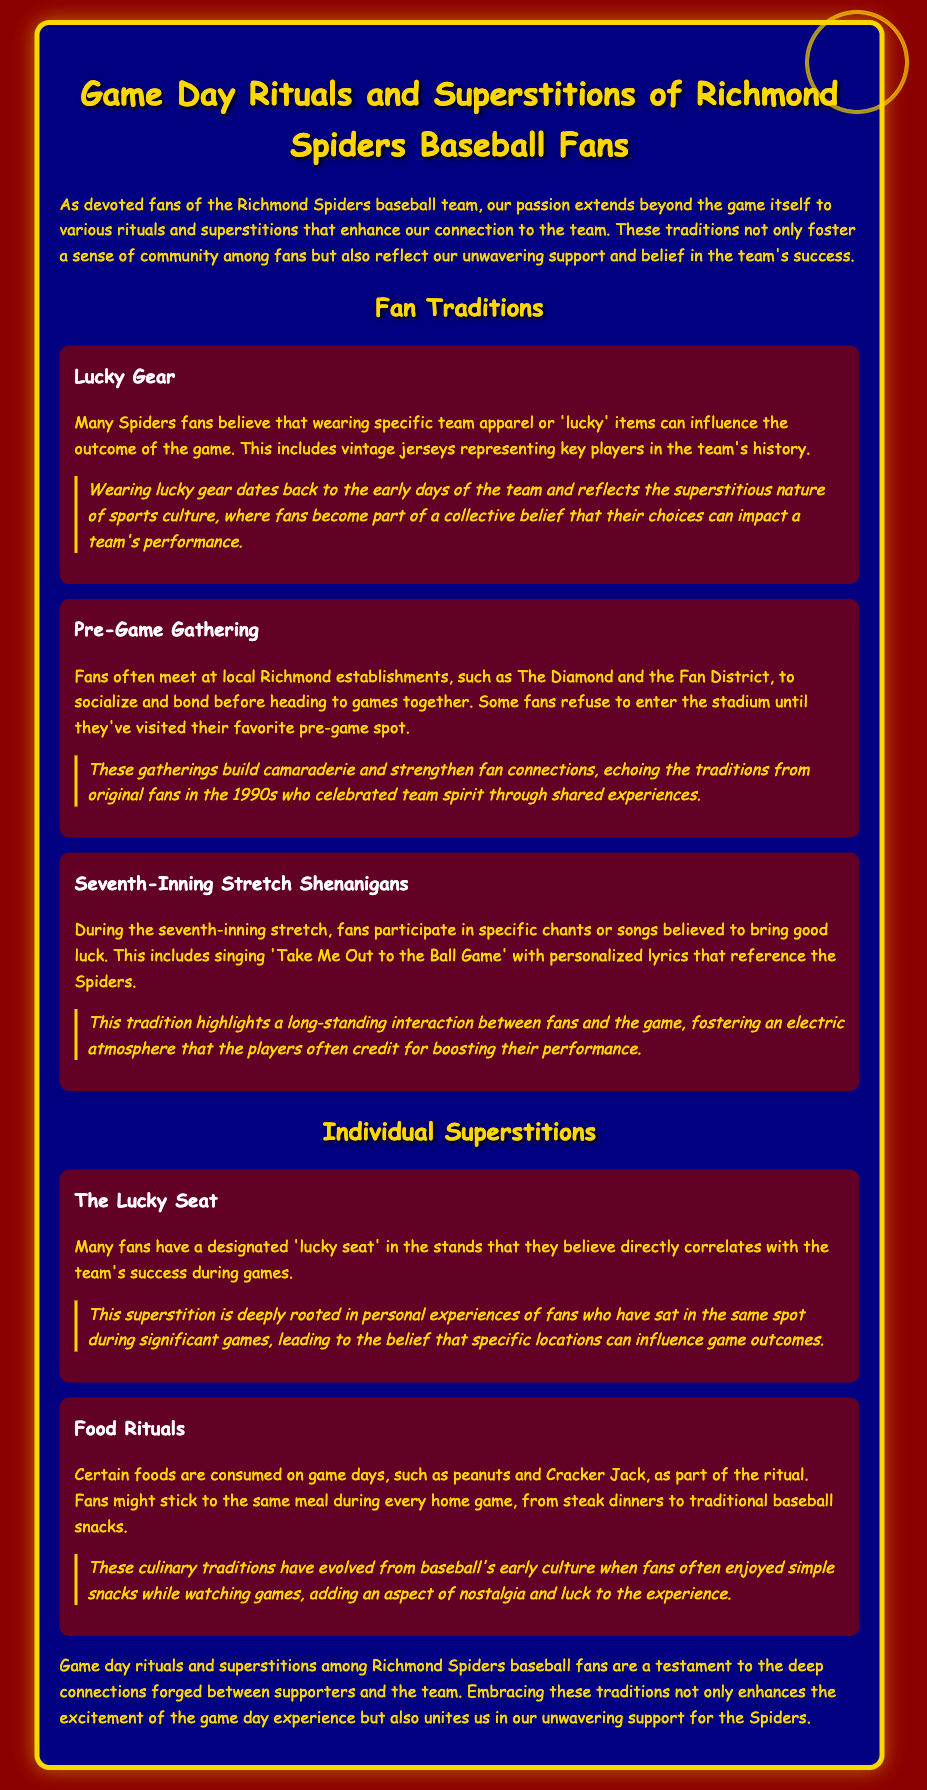what is the title of the memo? The title of the memo is located in the main heading at the top of the document.
Answer: Game Day Rituals and Superstitions of Richmond Spiders Baseball Fans what is the historical significance of wearing lucky gear? The historical significance is described in the section on "Lucky Gear," which explains the connection to sports culture.
Answer: Reflects the superstitious nature of sports culture what do fans do during the seventh-inning stretch? The activities during the seventh-inning stretch are outlined in specific mentions under the respective tradition.
Answer: Participate in specific chants or songs how many traditions are mentioned in the document? There are three traditions detailed in the memo.
Answer: Three what is a common food ritual mentioned for game days? The food ritual is noted in the section on "Food Rituals," highlighting what fans typically eat.
Answer: Peanuts and Cracker Jack what is the main purpose of pre-game gatherings? The purpose is explained in relation to building fan connections before games.
Answer: Build camaraderie and strengthen fan connections how does the superstition of the lucky seat relate to fan experiences? This connection is explained by referencing personal stories of fans in the document.
Answer: Specific locations can influence game outcomes what color scheme is used in the memo? The color scheme is described in the overall styling of the document.
Answer: Red and gold 